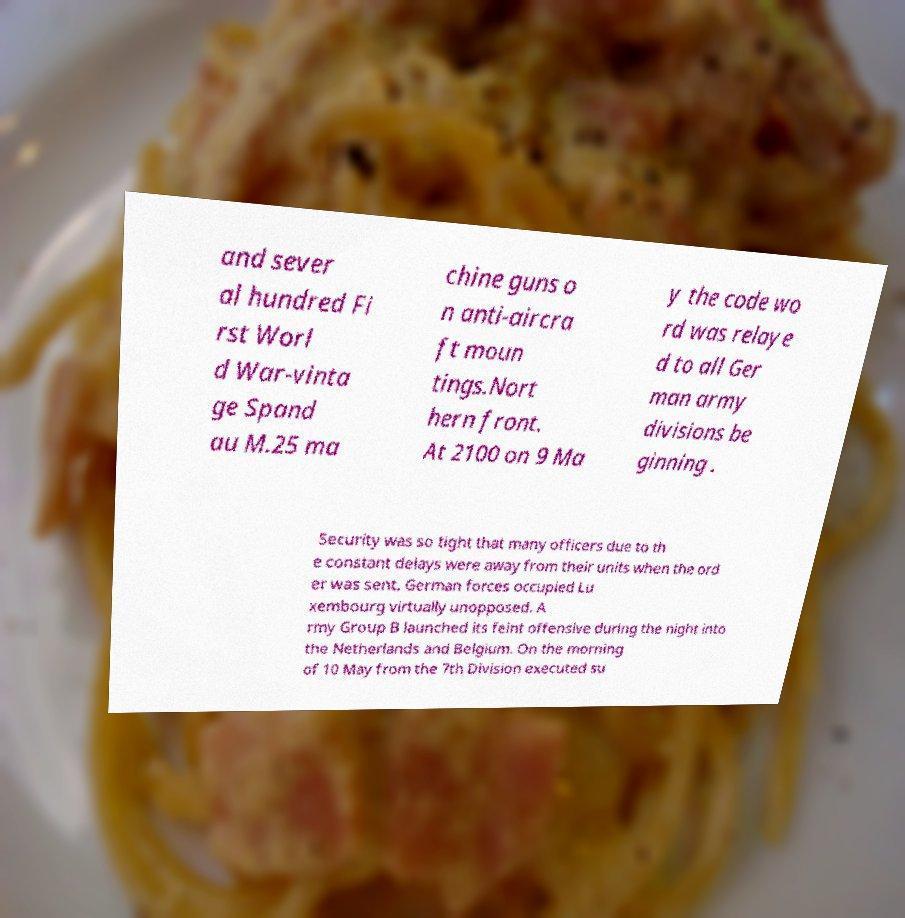Please identify and transcribe the text found in this image. and sever al hundred Fi rst Worl d War-vinta ge Spand au M.25 ma chine guns o n anti-aircra ft moun tings.Nort hern front. At 2100 on 9 Ma y the code wo rd was relaye d to all Ger man army divisions be ginning . Security was so tight that many officers due to th e constant delays were away from their units when the ord er was sent. German forces occupied Lu xembourg virtually unopposed. A rmy Group B launched its feint offensive during the night into the Netherlands and Belgium. On the morning of 10 May from the 7th Division executed su 